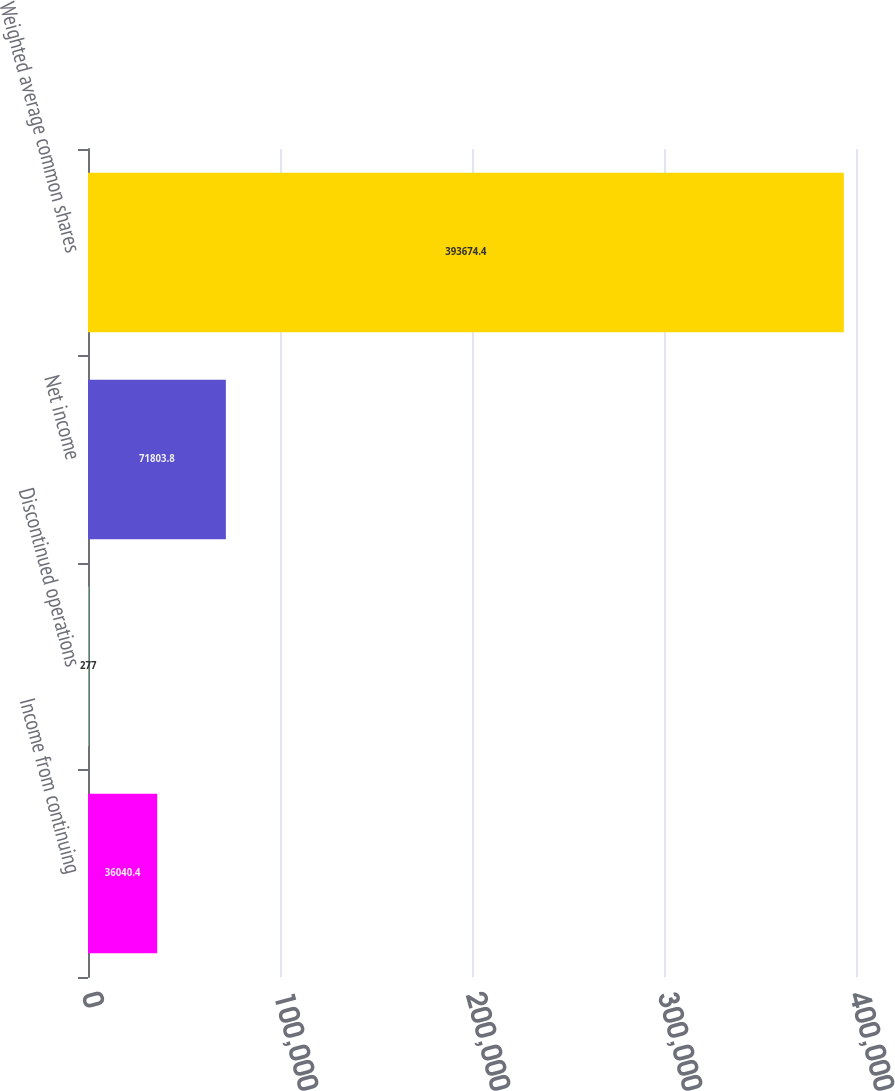Convert chart. <chart><loc_0><loc_0><loc_500><loc_500><bar_chart><fcel>Income from continuing<fcel>Discontinued operations<fcel>Net income<fcel>Weighted average common shares<nl><fcel>36040.4<fcel>277<fcel>71803.8<fcel>393674<nl></chart> 